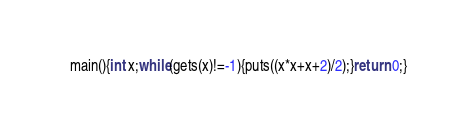<code> <loc_0><loc_0><loc_500><loc_500><_C_>main(){int x;while(gets(x)!=-1){puts((x*x+x+2)/2);}return 0;}</code> 